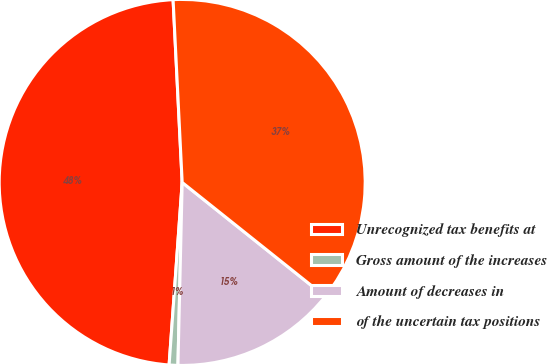Convert chart. <chart><loc_0><loc_0><loc_500><loc_500><pie_chart><fcel>Unrecognized tax benefits at<fcel>Gross amount of the increases<fcel>Amount of decreases in<fcel>of the uncertain tax positions<nl><fcel>48.07%<fcel>0.77%<fcel>14.65%<fcel>36.51%<nl></chart> 